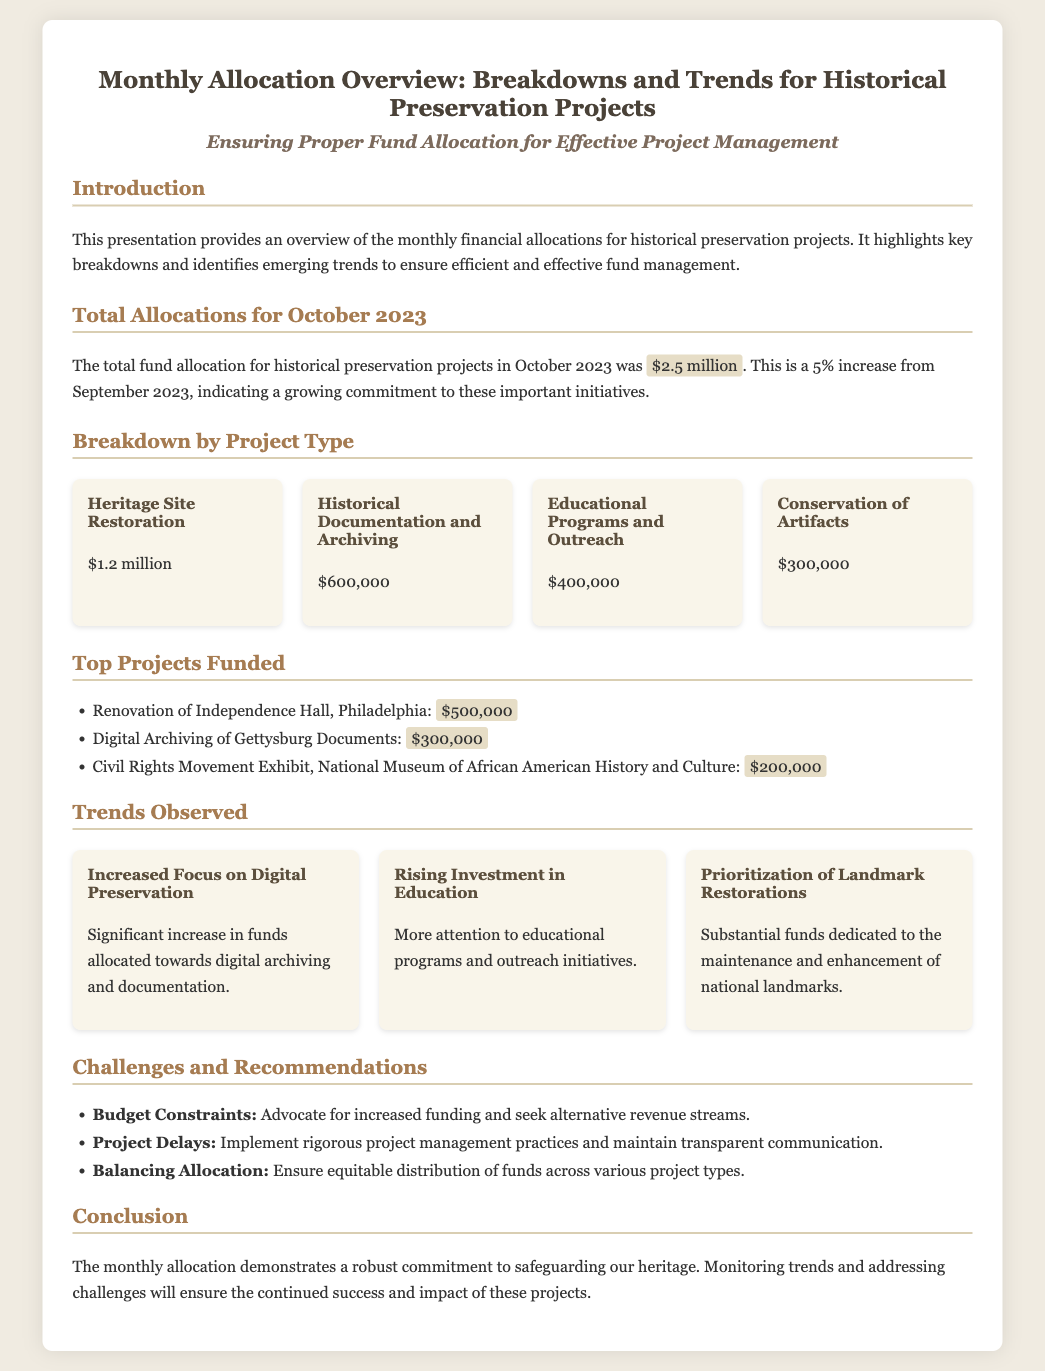What was the total fund allocation for October 2023? The total fund allocation for October 2023 is specifically stated in the document as $2.5 million.
Answer: $2.5 million What percentage increase does the October allocation represent from September 2023? The document mentions a 5% increase from the previous month, September 2023, to October 2023.
Answer: 5% What is the allocation amount for Heritage Site Restoration? The allocation amount for Heritage Site Restoration is explicitly mentioned in the breakdown by project type.
Answer: $1.2 million Which project received the highest funding? The document lists the top projects funded, with the Renovation of Independence Hall receiving the highest amount at $500,000.
Answer: Renovation of Independence Hall, Philadelphia What trend is observed concerning digital preservation? The document highlights the trend of increased focus on digital preservation as a significant observation in funding allocation.
Answer: Increased Focus on Digital Preservation What was one major challenge mentioned regarding fund allocation? The document identifies budget constraints as a key challenge, along with recommendations for addressing it.
Answer: Budget Constraints How many project types are detailed in the breakdown section? The breakdown section lists four distinct project types, allowing for easy identification of various allocation areas.
Answer: Four What is the primary goal of the presentation? The introduction specifies the goal of providing an overview of monthly financial allocations for effective project management in historical preservation.
Answer: Ensuring Proper Fund Allocation for Effective Project Management What type of projects has seen a rise in investment according to trends? The trends section indicates that educational programs and outreach initiatives have particularly seen a rising investment of funds.
Answer: Educational Programs and Outreach 